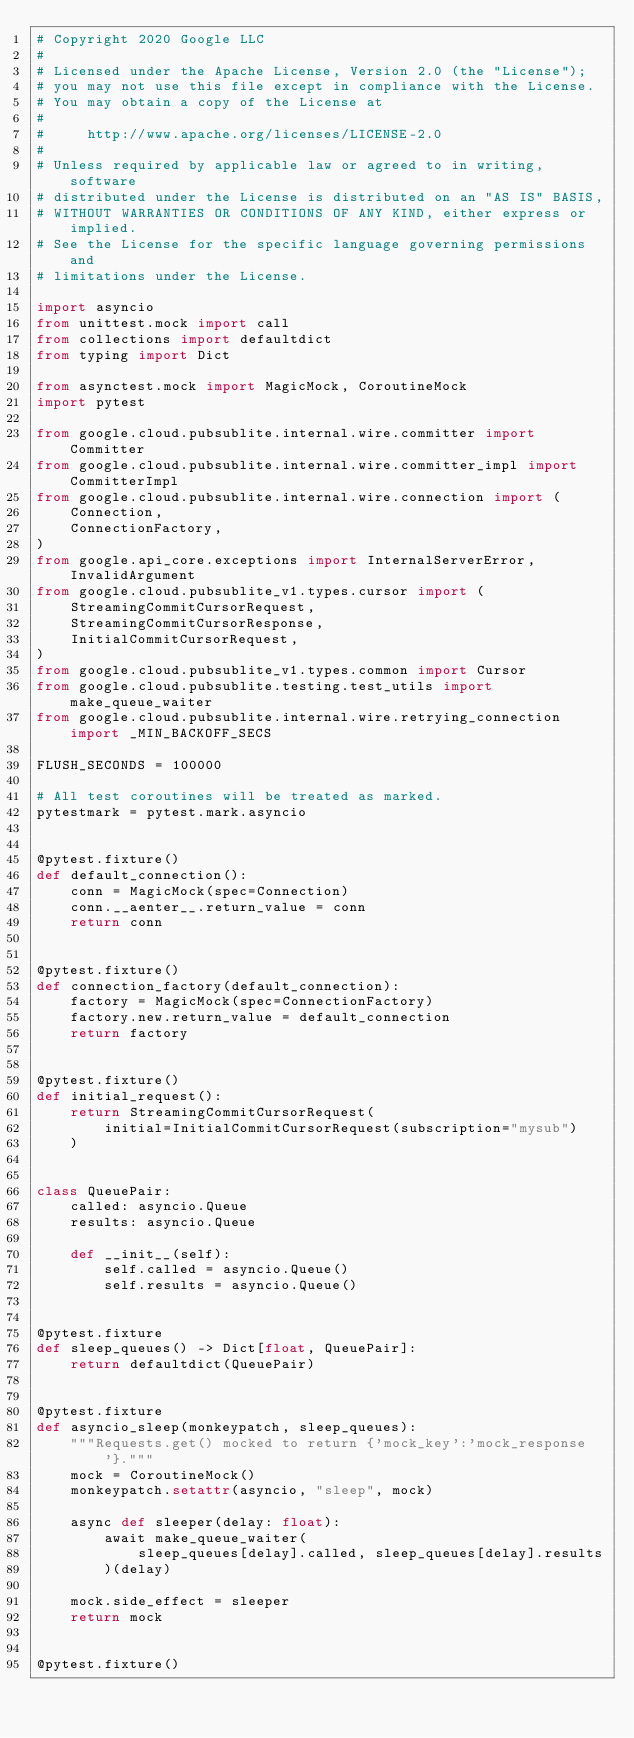Convert code to text. <code><loc_0><loc_0><loc_500><loc_500><_Python_># Copyright 2020 Google LLC
#
# Licensed under the Apache License, Version 2.0 (the "License");
# you may not use this file except in compliance with the License.
# You may obtain a copy of the License at
#
#     http://www.apache.org/licenses/LICENSE-2.0
#
# Unless required by applicable law or agreed to in writing, software
# distributed under the License is distributed on an "AS IS" BASIS,
# WITHOUT WARRANTIES OR CONDITIONS OF ANY KIND, either express or implied.
# See the License for the specific language governing permissions and
# limitations under the License.

import asyncio
from unittest.mock import call
from collections import defaultdict
from typing import Dict

from asynctest.mock import MagicMock, CoroutineMock
import pytest

from google.cloud.pubsublite.internal.wire.committer import Committer
from google.cloud.pubsublite.internal.wire.committer_impl import CommitterImpl
from google.cloud.pubsublite.internal.wire.connection import (
    Connection,
    ConnectionFactory,
)
from google.api_core.exceptions import InternalServerError, InvalidArgument
from google.cloud.pubsublite_v1.types.cursor import (
    StreamingCommitCursorRequest,
    StreamingCommitCursorResponse,
    InitialCommitCursorRequest,
)
from google.cloud.pubsublite_v1.types.common import Cursor
from google.cloud.pubsublite.testing.test_utils import make_queue_waiter
from google.cloud.pubsublite.internal.wire.retrying_connection import _MIN_BACKOFF_SECS

FLUSH_SECONDS = 100000

# All test coroutines will be treated as marked.
pytestmark = pytest.mark.asyncio


@pytest.fixture()
def default_connection():
    conn = MagicMock(spec=Connection)
    conn.__aenter__.return_value = conn
    return conn


@pytest.fixture()
def connection_factory(default_connection):
    factory = MagicMock(spec=ConnectionFactory)
    factory.new.return_value = default_connection
    return factory


@pytest.fixture()
def initial_request():
    return StreamingCommitCursorRequest(
        initial=InitialCommitCursorRequest(subscription="mysub")
    )


class QueuePair:
    called: asyncio.Queue
    results: asyncio.Queue

    def __init__(self):
        self.called = asyncio.Queue()
        self.results = asyncio.Queue()


@pytest.fixture
def sleep_queues() -> Dict[float, QueuePair]:
    return defaultdict(QueuePair)


@pytest.fixture
def asyncio_sleep(monkeypatch, sleep_queues):
    """Requests.get() mocked to return {'mock_key':'mock_response'}."""
    mock = CoroutineMock()
    monkeypatch.setattr(asyncio, "sleep", mock)

    async def sleeper(delay: float):
        await make_queue_waiter(
            sleep_queues[delay].called, sleep_queues[delay].results
        )(delay)

    mock.side_effect = sleeper
    return mock


@pytest.fixture()</code> 